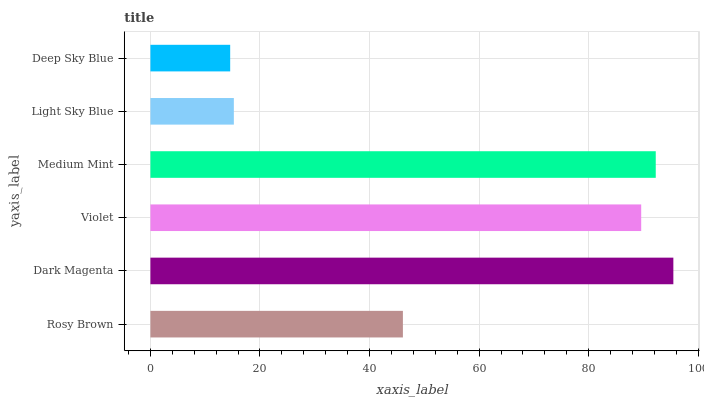Is Deep Sky Blue the minimum?
Answer yes or no. Yes. Is Dark Magenta the maximum?
Answer yes or no. Yes. Is Violet the minimum?
Answer yes or no. No. Is Violet the maximum?
Answer yes or no. No. Is Dark Magenta greater than Violet?
Answer yes or no. Yes. Is Violet less than Dark Magenta?
Answer yes or no. Yes. Is Violet greater than Dark Magenta?
Answer yes or no. No. Is Dark Magenta less than Violet?
Answer yes or no. No. Is Violet the high median?
Answer yes or no. Yes. Is Rosy Brown the low median?
Answer yes or no. Yes. Is Deep Sky Blue the high median?
Answer yes or no. No. Is Medium Mint the low median?
Answer yes or no. No. 